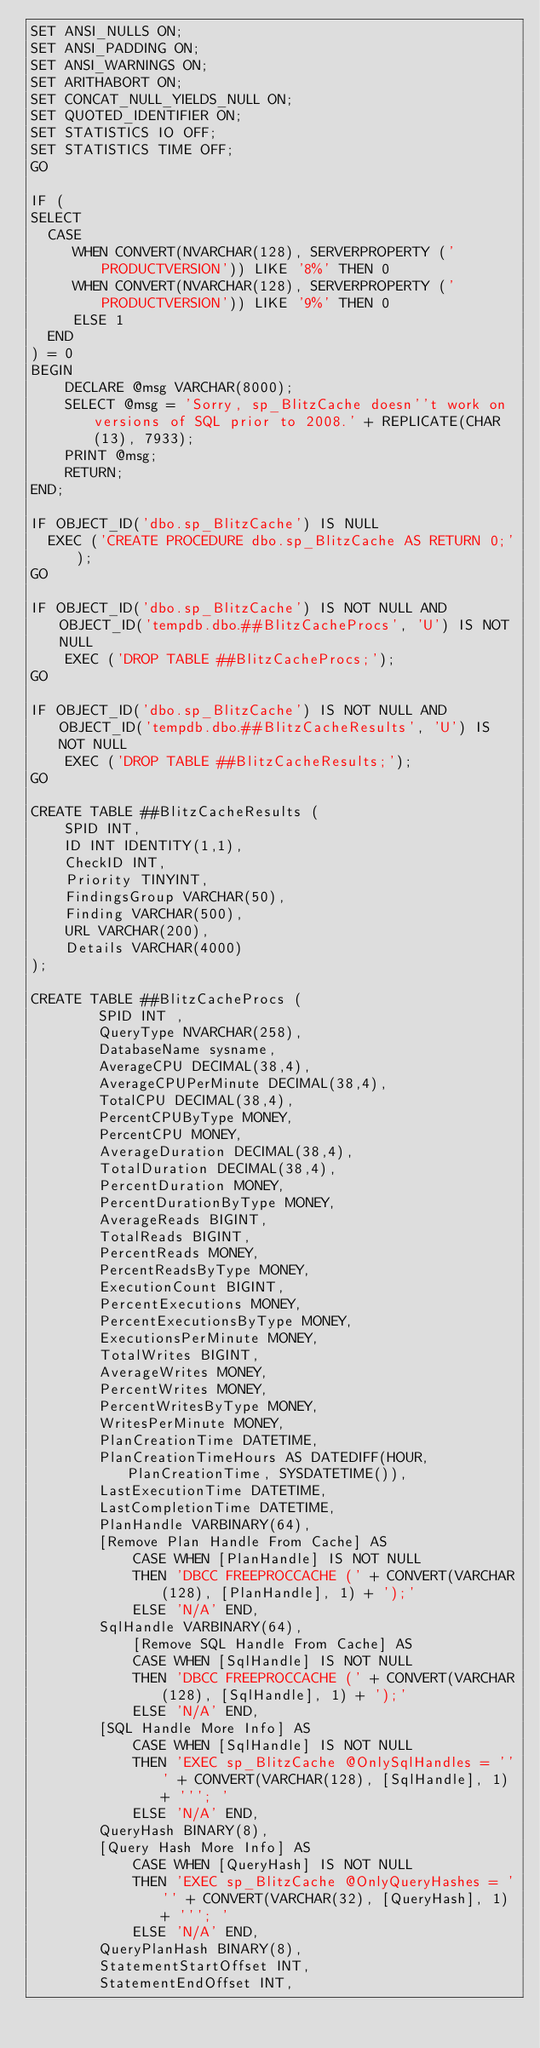Convert code to text. <code><loc_0><loc_0><loc_500><loc_500><_SQL_>SET ANSI_NULLS ON;
SET ANSI_PADDING ON;
SET ANSI_WARNINGS ON;
SET ARITHABORT ON;
SET CONCAT_NULL_YIELDS_NULL ON;
SET QUOTED_IDENTIFIER ON;
SET STATISTICS IO OFF;
SET STATISTICS TIME OFF;
GO

IF (
SELECT
  CASE 
     WHEN CONVERT(NVARCHAR(128), SERVERPROPERTY ('PRODUCTVERSION')) LIKE '8%' THEN 0
     WHEN CONVERT(NVARCHAR(128), SERVERPROPERTY ('PRODUCTVERSION')) LIKE '9%' THEN 0
	 ELSE 1
  END 
) = 0
BEGIN
	DECLARE @msg VARCHAR(8000); 
	SELECT @msg = 'Sorry, sp_BlitzCache doesn''t work on versions of SQL prior to 2008.' + REPLICATE(CHAR(13), 7933);
	PRINT @msg;
	RETURN;
END;

IF OBJECT_ID('dbo.sp_BlitzCache') IS NULL
  EXEC ('CREATE PROCEDURE dbo.sp_BlitzCache AS RETURN 0;');
GO

IF OBJECT_ID('dbo.sp_BlitzCache') IS NOT NULL AND OBJECT_ID('tempdb.dbo.##BlitzCacheProcs', 'U') IS NOT NULL
    EXEC ('DROP TABLE ##BlitzCacheProcs;');
GO

IF OBJECT_ID('dbo.sp_BlitzCache') IS NOT NULL AND OBJECT_ID('tempdb.dbo.##BlitzCacheResults', 'U') IS NOT NULL
    EXEC ('DROP TABLE ##BlitzCacheResults;');
GO

CREATE TABLE ##BlitzCacheResults (
    SPID INT,
    ID INT IDENTITY(1,1),
    CheckID INT,
    Priority TINYINT,
    FindingsGroup VARCHAR(50),
    Finding VARCHAR(500),
    URL VARCHAR(200),
    Details VARCHAR(4000) 
);

CREATE TABLE ##BlitzCacheProcs (
        SPID INT ,
        QueryType NVARCHAR(258),
        DatabaseName sysname,
        AverageCPU DECIMAL(38,4),
        AverageCPUPerMinute DECIMAL(38,4),
        TotalCPU DECIMAL(38,4),
        PercentCPUByType MONEY,
        PercentCPU MONEY,
        AverageDuration DECIMAL(38,4),
        TotalDuration DECIMAL(38,4),
        PercentDuration MONEY,
        PercentDurationByType MONEY,
        AverageReads BIGINT,
        TotalReads BIGINT,
        PercentReads MONEY,
        PercentReadsByType MONEY,
        ExecutionCount BIGINT,
        PercentExecutions MONEY,
        PercentExecutionsByType MONEY,
        ExecutionsPerMinute MONEY,
        TotalWrites BIGINT,
        AverageWrites MONEY,
        PercentWrites MONEY,
        PercentWritesByType MONEY,
        WritesPerMinute MONEY,
        PlanCreationTime DATETIME,
		PlanCreationTimeHours AS DATEDIFF(HOUR, PlanCreationTime, SYSDATETIME()),
        LastExecutionTime DATETIME,
		LastCompletionTime DATETIME,
        PlanHandle VARBINARY(64),
		[Remove Plan Handle From Cache] AS 
			CASE WHEN [PlanHandle] IS NOT NULL 
			THEN 'DBCC FREEPROCCACHE (' + CONVERT(VARCHAR(128), [PlanHandle], 1) + ');'
			ELSE 'N/A' END,
		SqlHandle VARBINARY(64),
			[Remove SQL Handle From Cache] AS 
			CASE WHEN [SqlHandle] IS NOT NULL 
			THEN 'DBCC FREEPROCCACHE (' + CONVERT(VARCHAR(128), [SqlHandle], 1) + ');'
			ELSE 'N/A' END,
		[SQL Handle More Info] AS 
			CASE WHEN [SqlHandle] IS NOT NULL 
			THEN 'EXEC sp_BlitzCache @OnlySqlHandles = ''' + CONVERT(VARCHAR(128), [SqlHandle], 1) + '''; '
			ELSE 'N/A' END,
		QueryHash BINARY(8),
		[Query Hash More Info] AS 
			CASE WHEN [QueryHash] IS NOT NULL 
			THEN 'EXEC sp_BlitzCache @OnlyQueryHashes = ''' + CONVERT(VARCHAR(32), [QueryHash], 1) + '''; '
			ELSE 'N/A' END,
        QueryPlanHash BINARY(8),
        StatementStartOffset INT,
        StatementEndOffset INT,</code> 